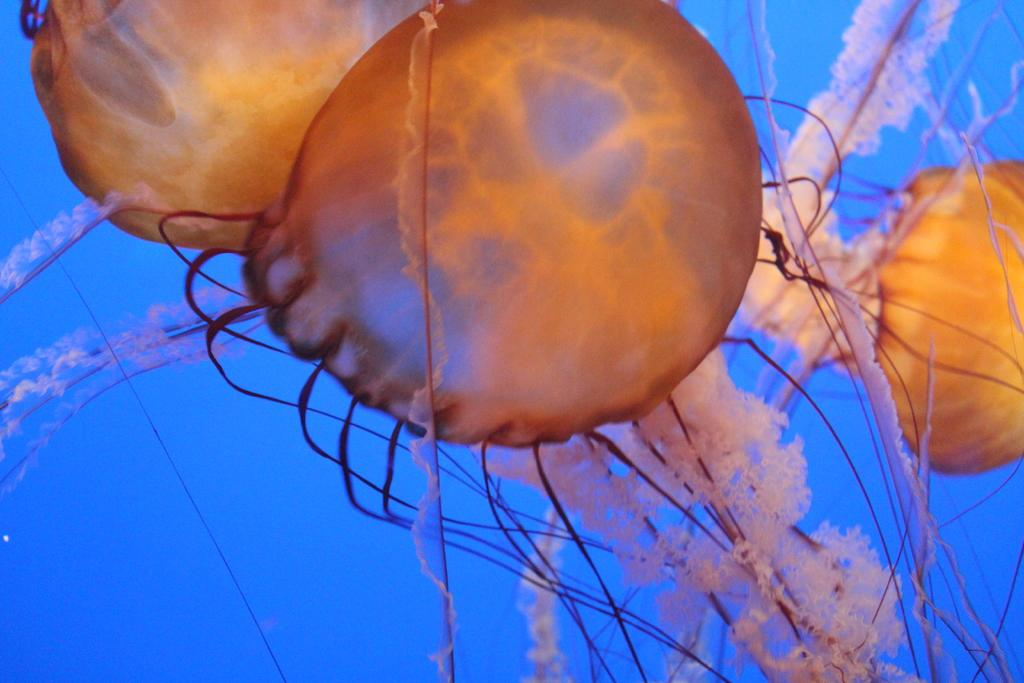What type of animals are in the image? There are jellyfishes in the image. Where are the jellyfishes located? The jellyfishes are in the water. Can you see a girl holding her breath while watching the jellyfishes in the image? There is no girl present in the image, and the jellyfishes are in the water, so it is not possible to see anyone holding their breath while watching them. 